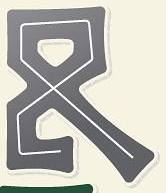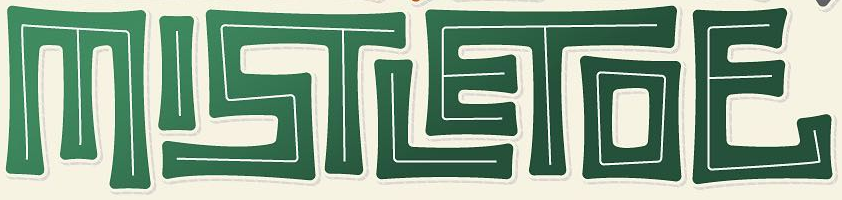What text is displayed in these images sequentially, separated by a semicolon? &; MISTLETOE 